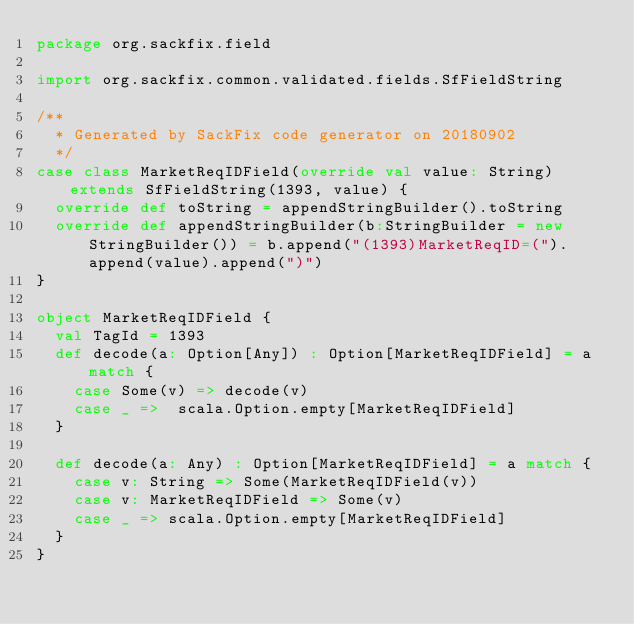<code> <loc_0><loc_0><loc_500><loc_500><_Scala_>package org.sackfix.field

import org.sackfix.common.validated.fields.SfFieldString

/**
  * Generated by SackFix code generator on 20180902
  */
case class MarketReqIDField(override val value: String) extends SfFieldString(1393, value) {
  override def toString = appendStringBuilder().toString
  override def appendStringBuilder(b:StringBuilder = new StringBuilder()) = b.append("(1393)MarketReqID=(").append(value).append(")")
}

object MarketReqIDField {
  val TagId = 1393  
  def decode(a: Option[Any]) : Option[MarketReqIDField] = a match {
    case Some(v) => decode(v)
    case _ =>  scala.Option.empty[MarketReqIDField]
  }

  def decode(a: Any) : Option[MarketReqIDField] = a match {
    case v: String => Some(MarketReqIDField(v))
    case v: MarketReqIDField => Some(v)
    case _ => scala.Option.empty[MarketReqIDField]
  } 
}
</code> 